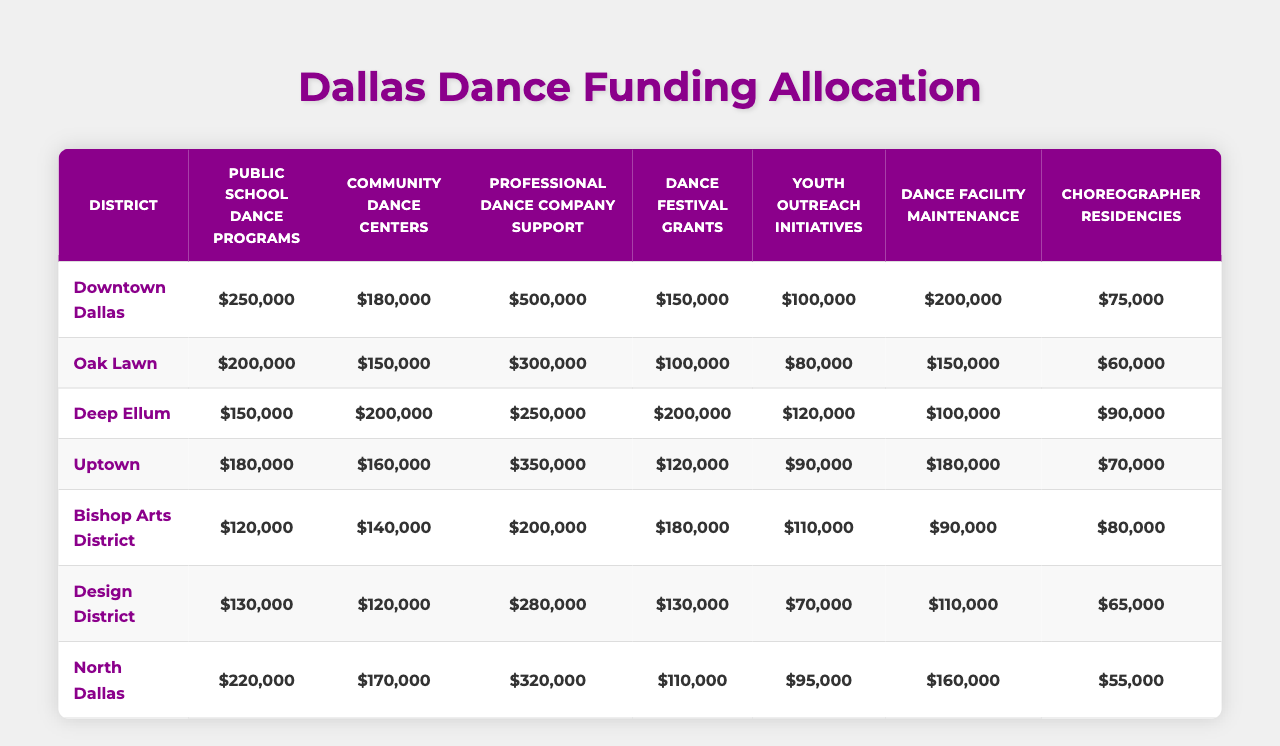What's the funding allocated for Public School Dance Programs in North Dallas? The table shows that North Dallas received $220,000 for Public School Dance Programs.
Answer: $220,000 Which district has the highest funding for Professional Dance Company Support? Comparing the values in the table, Downtown Dallas has the highest funding for Professional Dance Company Support at $500,000.
Answer: Downtown Dallas What is the total funding allocated for Community Dance Centers across all districts? We sum the values: 180,000 + 150,000 + 200,000 + 160,000 + 140,000 + 120,000 + 170,000 = 1,120,000.
Answer: $1,120,000 Is the funding for Dance Festival Grants in Deep Ellum more than in Uptown? Deep Ellum received $200,000 while Uptown received $120,000, thus Deep Ellum's funding is greater.
Answer: Yes What is the average funding allocation for Youth Outreach Initiatives across all districts? The total funding is 100,000 + 80,000 + 120,000 + 90,000 + 110,000 + 70,000 + 95,000 = 765,000 and dividing by 7 districts gives an average of 765,000 / 7 ≈ 109,286.
Answer: Approximately $109,286 How much more funding does the Bishop Arts District receive for Dance Facility Maintenance compared to North Dallas? Bishop Arts District has $90,000 while North Dallas has $160,000. Therefore, Bishop Arts District receives $90,000 - $160,000 = -$70,000, meaning North Dallas has $70,000 more.
Answer: $70,000 Which district has the least funding for Choreographer Residencies? The table shows that North Dallas has the least funding for Choreographer Residencies at $55,000.
Answer: North Dallas What is the total funding for Public School Dance Programs in Uptown and Oak Lawn combined? Adding the values together gives us 180,000 (Uptown) + 200,000 (Oak Lawn) = 380,000.
Answer: $380,000 Does any district receive zero funding for any of the categories? Looking through the table, there are no indications of zero funding in any district for any category.
Answer: No How does the total funding for Dance Facility Maintenance in Downtown Dallas compare to that in the Design District? Downtown Dallas has $200,000 while the Design District has $110,000, indicating Downtown has $90,000 more.
Answer: Downtown Dallas has $90,000 more 